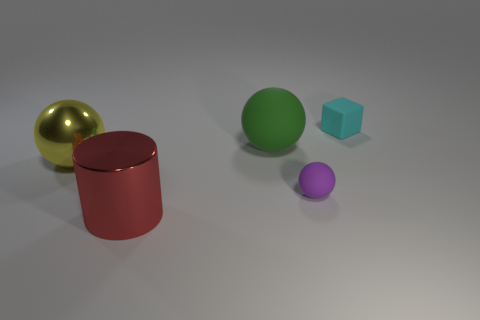Subtract all small rubber spheres. How many spheres are left? 2 Subtract all green spheres. How many spheres are left? 2 Subtract all balls. How many objects are left? 2 Add 5 green rubber objects. How many objects exist? 10 Add 4 green objects. How many green objects are left? 5 Add 4 cylinders. How many cylinders exist? 5 Subtract 0 gray balls. How many objects are left? 5 Subtract all brown cylinders. Subtract all gray cubes. How many cylinders are left? 1 Subtract all blue cylinders. How many green balls are left? 1 Subtract all blue spheres. Subtract all small rubber things. How many objects are left? 3 